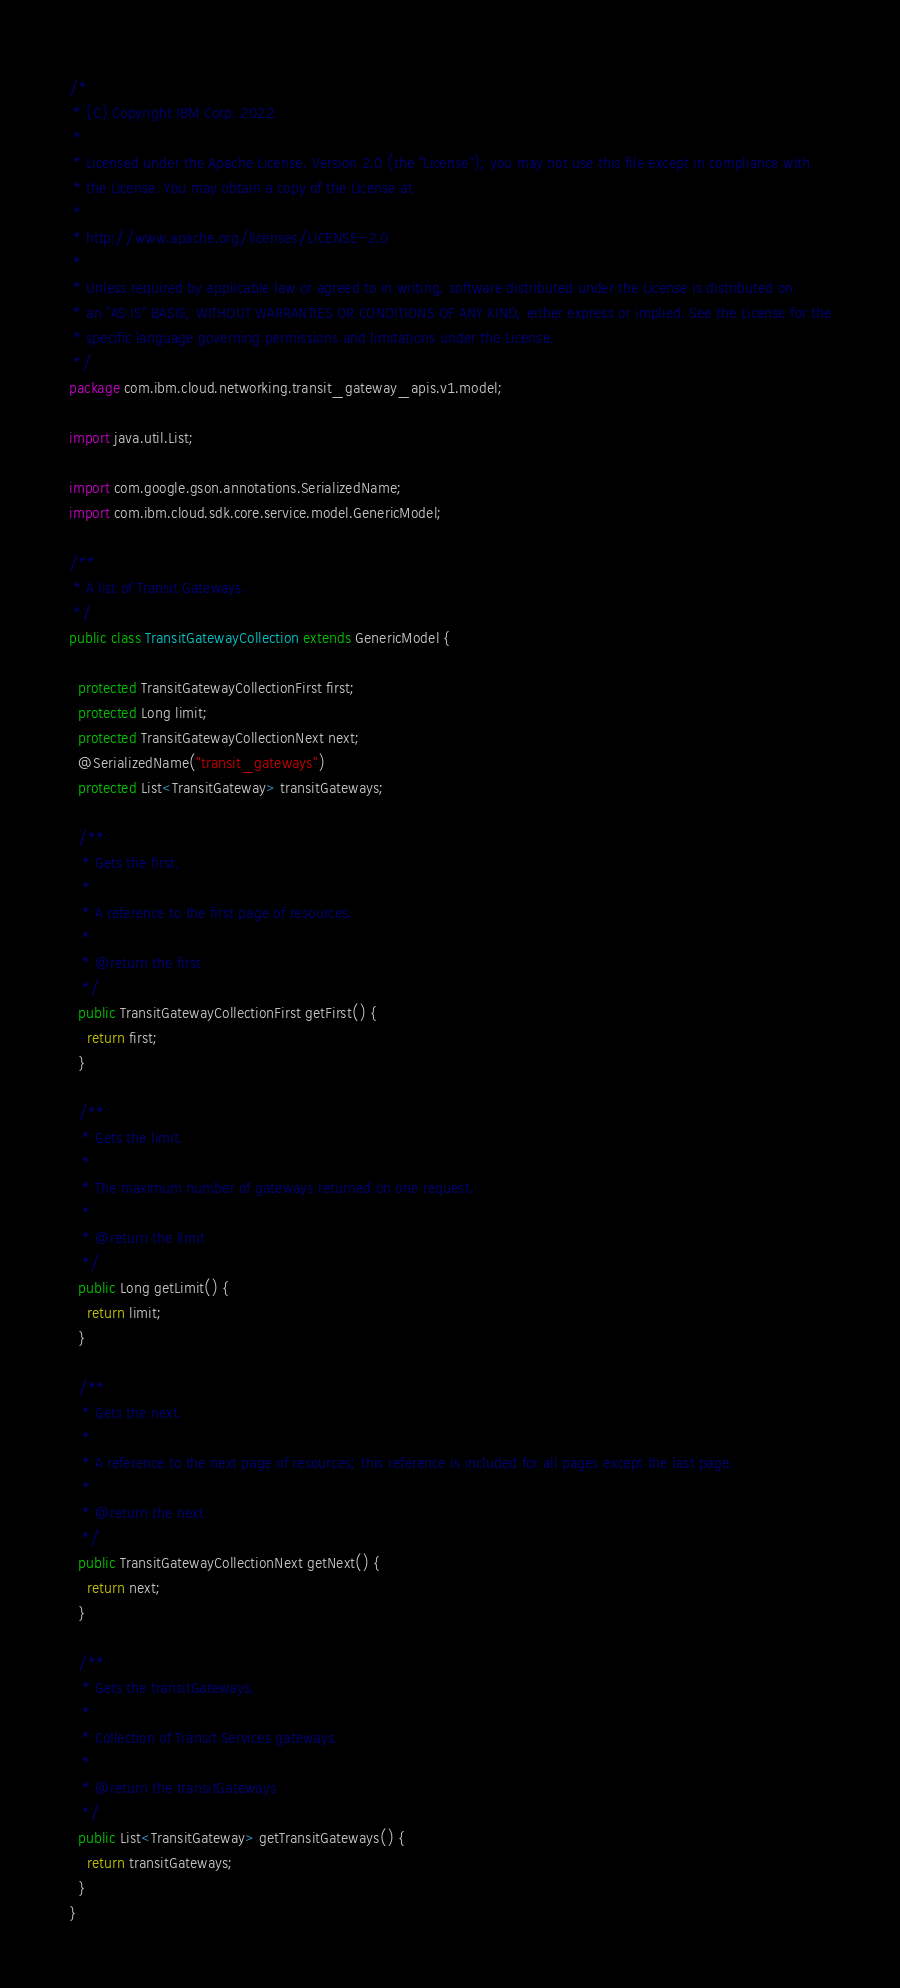<code> <loc_0><loc_0><loc_500><loc_500><_Java_>/*
 * (C) Copyright IBM Corp. 2022.
 *
 * Licensed under the Apache License, Version 2.0 (the "License"); you may not use this file except in compliance with
 * the License. You may obtain a copy of the License at
 *
 * http://www.apache.org/licenses/LICENSE-2.0
 *
 * Unless required by applicable law or agreed to in writing, software distributed under the License is distributed on
 * an "AS IS" BASIS, WITHOUT WARRANTIES OR CONDITIONS OF ANY KIND, either express or implied. See the License for the
 * specific language governing permissions and limitations under the License.
 */
package com.ibm.cloud.networking.transit_gateway_apis.v1.model;

import java.util.List;

import com.google.gson.annotations.SerializedName;
import com.ibm.cloud.sdk.core.service.model.GenericModel;

/**
 * A list of Transit Gateways.
 */
public class TransitGatewayCollection extends GenericModel {

  protected TransitGatewayCollectionFirst first;
  protected Long limit;
  protected TransitGatewayCollectionNext next;
  @SerializedName("transit_gateways")
  protected List<TransitGateway> transitGateways;

  /**
   * Gets the first.
   *
   * A reference to the first page of resources.
   *
   * @return the first
   */
  public TransitGatewayCollectionFirst getFirst() {
    return first;
  }

  /**
   * Gets the limit.
   *
   * The maximum number of gateways returned on one request.
   *
   * @return the limit
   */
  public Long getLimit() {
    return limit;
  }

  /**
   * Gets the next.
   *
   * A reference to the next page of resources; this reference is included for all pages except the last page.
   *
   * @return the next
   */
  public TransitGatewayCollectionNext getNext() {
    return next;
  }

  /**
   * Gets the transitGateways.
   *
   * Collection of Transit Services gateways.
   *
   * @return the transitGateways
   */
  public List<TransitGateway> getTransitGateways() {
    return transitGateways;
  }
}

</code> 